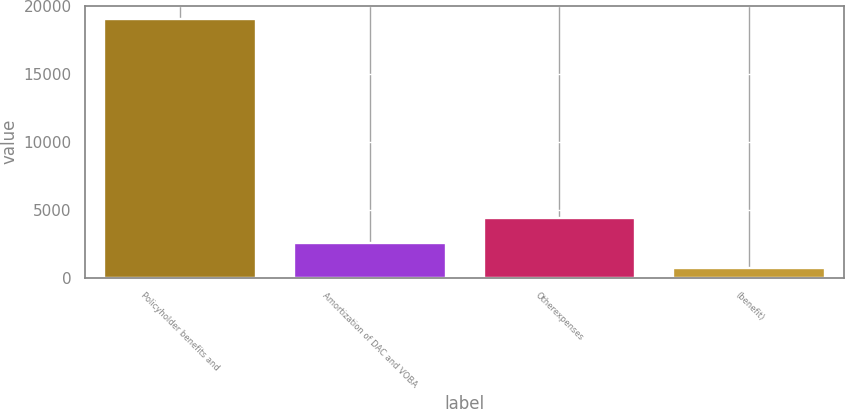<chart> <loc_0><loc_0><loc_500><loc_500><bar_chart><fcel>Policyholder benefits and<fcel>Amortization of DAC and VOBA<fcel>Otherexpenses<fcel>(benefit)<nl><fcel>19075<fcel>2547.4<fcel>4383.8<fcel>711<nl></chart> 